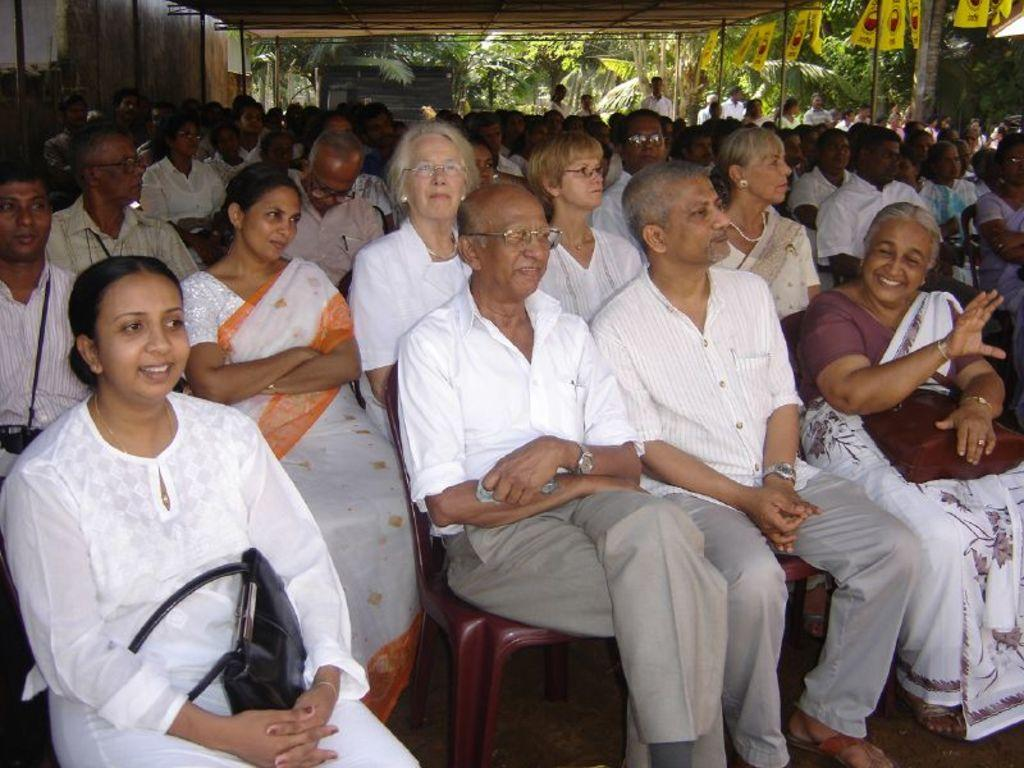What are the people in the image doing? There is a group of people sitting on chairs and a group of people standing in the image. What can be seen hanging in the image? There are banners in the image. What is visible in the background of the image? There are trees in the background of the image. Where is the hydrant located in the image? There is no hydrant present in the image. What type of poison is being used by the people in the image? There is no mention of poison or any dangerous substances in the image. 